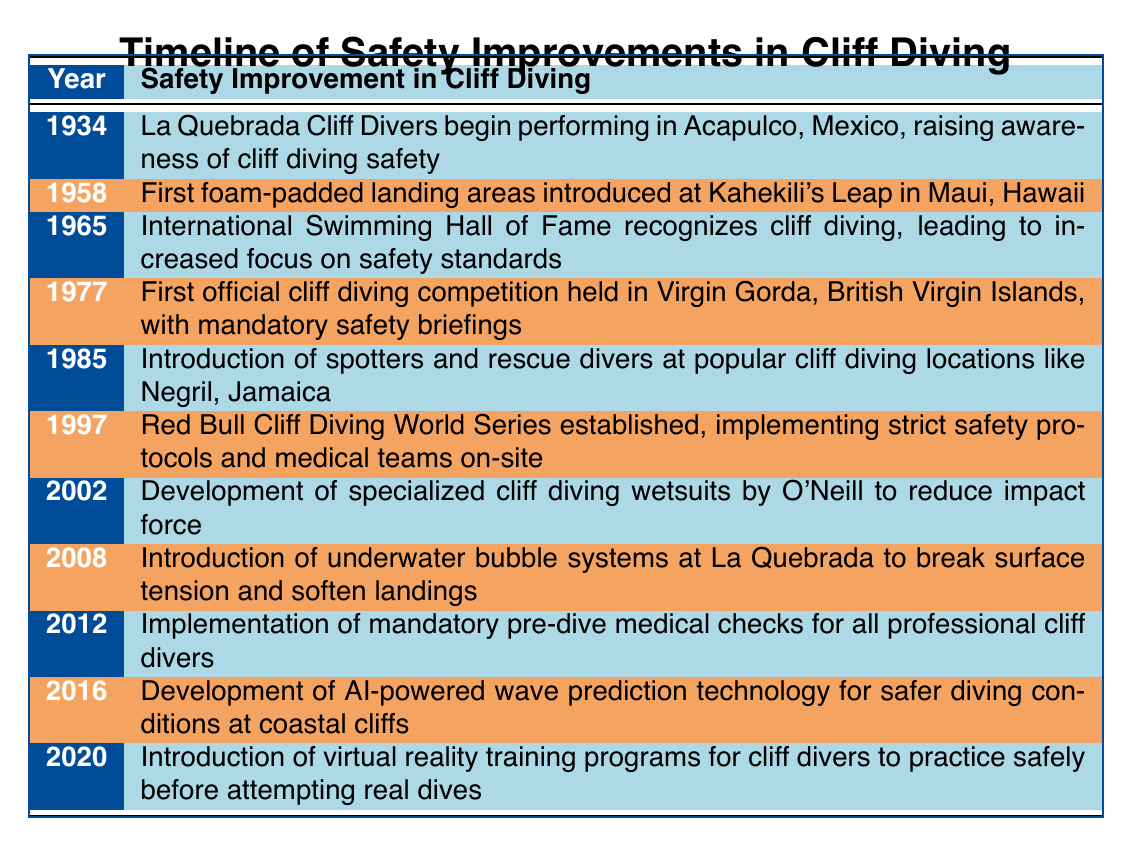What year did La Quebrada Cliff Divers begin performing? The table lists the event associated with La Quebrada Cliff Divers in 1934, which states that they began performing in Acapulco, Mexico.
Answer: 1934 What safety improvement was introduced in 1958? According to the table, the event in 1958 mentions the introduction of foam-padded landing areas at Kahekili's Leap in Maui, Hawaii.
Answer: Foam-padded landing areas In which year was the Red Bull Cliff Diving World Series established? The table explicitly states that the Red Bull Cliff Diving World Series was established in 1997.
Answer: 1997 True or False: Mandatory pre-dive medical checks were implemented before 2012. By looking at the timeline, the first mention of mandatory pre-dive medical checks is in 2012, indicating that it was not implemented prior to that year.
Answer: False What were the two safety improvements introduced in the 2000s? The timeline indicates two significant improvements in the 2000s: the development of specialized wetsuits in 2002 and the underwater bubble systems introduced in 2008.
Answer: Specialized wetsuits and underwater bubble systems Which event led to increased focus on safety standards in cliff diving? The table explains that the recognition of cliff diving by the International Swimming Hall of Fame in 1965 led to an increased focus on safety standards.
Answer: Recognition by the International Swimming Hall of Fame How many years passed between the introduction of spotters and rescue divers and the first official cliff diving competition? The first official competition occurred in 1977, while spotters and rescue divers were introduced in 1985. To find the difference, calculate 1985 - 1977 = 8 years.
Answer: 8 years Which safety improvement was first associated with mandatory safety briefings? According to the table, the first official cliff diving competition in 1977 included mandatory safety briefings, linking this safety improvement to that event.
Answer: Mandatory safety briefings True or False: AI-powered wave prediction technology was developed after 2016. The table states that AI-powered wave prediction technology was developed in 2016, meaning it cannot have occurred after that year.
Answer: False 